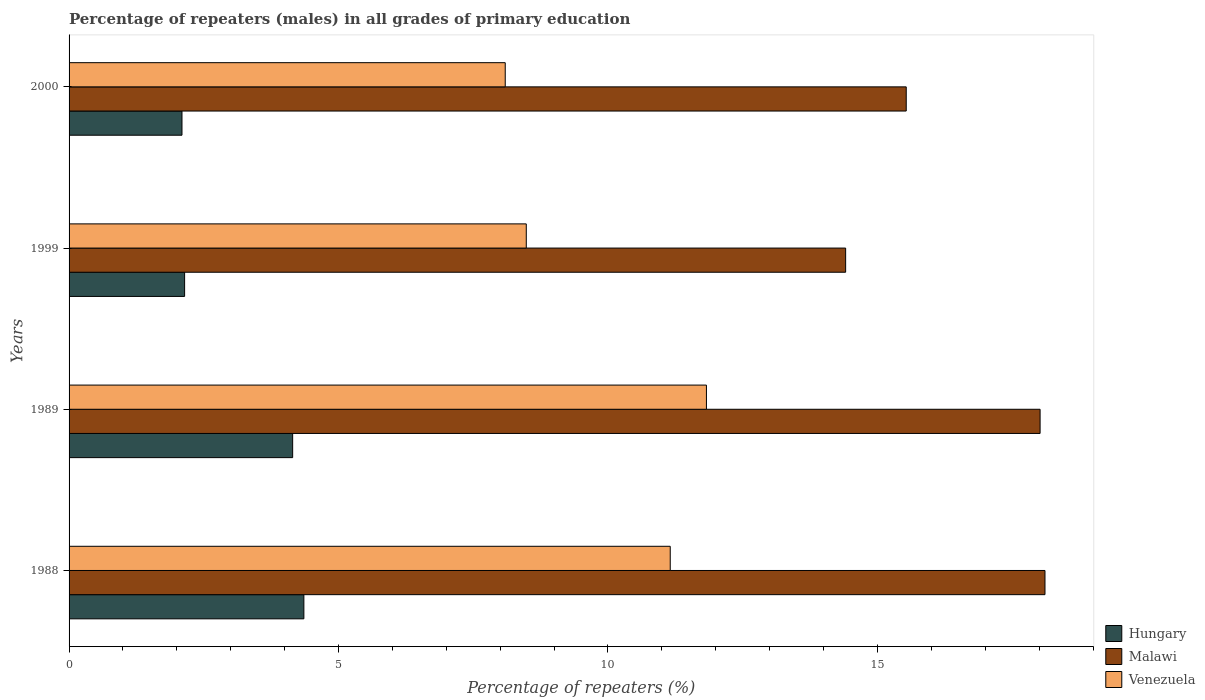How many different coloured bars are there?
Keep it short and to the point. 3. How many groups of bars are there?
Make the answer very short. 4. Are the number of bars per tick equal to the number of legend labels?
Your answer should be very brief. Yes. What is the label of the 4th group of bars from the top?
Keep it short and to the point. 1988. In how many cases, is the number of bars for a given year not equal to the number of legend labels?
Ensure brevity in your answer.  0. What is the percentage of repeaters (males) in Malawi in 1989?
Offer a very short reply. 18.02. Across all years, what is the maximum percentage of repeaters (males) in Malawi?
Provide a short and direct response. 18.11. Across all years, what is the minimum percentage of repeaters (males) in Venezuela?
Your answer should be very brief. 8.09. In which year was the percentage of repeaters (males) in Malawi maximum?
Offer a very short reply. 1988. In which year was the percentage of repeaters (males) in Malawi minimum?
Your answer should be compact. 1999. What is the total percentage of repeaters (males) in Venezuela in the graph?
Give a very brief answer. 39.56. What is the difference between the percentage of repeaters (males) in Hungary in 1988 and that in 1989?
Ensure brevity in your answer.  0.21. What is the difference between the percentage of repeaters (males) in Malawi in 2000 and the percentage of repeaters (males) in Venezuela in 1989?
Make the answer very short. 3.71. What is the average percentage of repeaters (males) in Malawi per year?
Provide a short and direct response. 16.52. In the year 2000, what is the difference between the percentage of repeaters (males) in Malawi and percentage of repeaters (males) in Venezuela?
Ensure brevity in your answer.  7.44. What is the ratio of the percentage of repeaters (males) in Hungary in 1989 to that in 1999?
Ensure brevity in your answer.  1.94. Is the percentage of repeaters (males) in Hungary in 1999 less than that in 2000?
Give a very brief answer. No. What is the difference between the highest and the second highest percentage of repeaters (males) in Malawi?
Your answer should be very brief. 0.09. What is the difference between the highest and the lowest percentage of repeaters (males) in Venezuela?
Make the answer very short. 3.73. In how many years, is the percentage of repeaters (males) in Malawi greater than the average percentage of repeaters (males) in Malawi taken over all years?
Offer a very short reply. 2. Is the sum of the percentage of repeaters (males) in Hungary in 1989 and 1999 greater than the maximum percentage of repeaters (males) in Venezuela across all years?
Give a very brief answer. No. What does the 3rd bar from the top in 1989 represents?
Your answer should be compact. Hungary. What does the 3rd bar from the bottom in 1999 represents?
Provide a succinct answer. Venezuela. Is it the case that in every year, the sum of the percentage of repeaters (males) in Venezuela and percentage of repeaters (males) in Hungary is greater than the percentage of repeaters (males) in Malawi?
Your response must be concise. No. How many bars are there?
Keep it short and to the point. 12. Are the values on the major ticks of X-axis written in scientific E-notation?
Keep it short and to the point. No. Does the graph contain any zero values?
Keep it short and to the point. No. How are the legend labels stacked?
Keep it short and to the point. Vertical. What is the title of the graph?
Give a very brief answer. Percentage of repeaters (males) in all grades of primary education. Does "Gambia, The" appear as one of the legend labels in the graph?
Offer a very short reply. No. What is the label or title of the X-axis?
Your answer should be very brief. Percentage of repeaters (%). What is the Percentage of repeaters (%) of Hungary in 1988?
Your answer should be compact. 4.36. What is the Percentage of repeaters (%) of Malawi in 1988?
Your answer should be very brief. 18.11. What is the Percentage of repeaters (%) in Venezuela in 1988?
Ensure brevity in your answer.  11.16. What is the Percentage of repeaters (%) of Hungary in 1989?
Your answer should be very brief. 4.15. What is the Percentage of repeaters (%) of Malawi in 1989?
Offer a terse response. 18.02. What is the Percentage of repeaters (%) of Venezuela in 1989?
Provide a succinct answer. 11.83. What is the Percentage of repeaters (%) of Hungary in 1999?
Ensure brevity in your answer.  2.14. What is the Percentage of repeaters (%) of Malawi in 1999?
Your answer should be very brief. 14.41. What is the Percentage of repeaters (%) of Venezuela in 1999?
Make the answer very short. 8.48. What is the Percentage of repeaters (%) in Hungary in 2000?
Offer a very short reply. 2.1. What is the Percentage of repeaters (%) of Malawi in 2000?
Give a very brief answer. 15.53. What is the Percentage of repeaters (%) in Venezuela in 2000?
Offer a very short reply. 8.09. Across all years, what is the maximum Percentage of repeaters (%) of Hungary?
Offer a terse response. 4.36. Across all years, what is the maximum Percentage of repeaters (%) in Malawi?
Your answer should be compact. 18.11. Across all years, what is the maximum Percentage of repeaters (%) in Venezuela?
Provide a short and direct response. 11.83. Across all years, what is the minimum Percentage of repeaters (%) of Hungary?
Make the answer very short. 2.1. Across all years, what is the minimum Percentage of repeaters (%) of Malawi?
Provide a short and direct response. 14.41. Across all years, what is the minimum Percentage of repeaters (%) of Venezuela?
Offer a very short reply. 8.09. What is the total Percentage of repeaters (%) of Hungary in the graph?
Offer a terse response. 12.75. What is the total Percentage of repeaters (%) of Malawi in the graph?
Provide a short and direct response. 66.07. What is the total Percentage of repeaters (%) of Venezuela in the graph?
Provide a short and direct response. 39.56. What is the difference between the Percentage of repeaters (%) in Hungary in 1988 and that in 1989?
Your answer should be very brief. 0.21. What is the difference between the Percentage of repeaters (%) of Malawi in 1988 and that in 1989?
Provide a short and direct response. 0.09. What is the difference between the Percentage of repeaters (%) in Venezuela in 1988 and that in 1989?
Make the answer very short. -0.67. What is the difference between the Percentage of repeaters (%) of Hungary in 1988 and that in 1999?
Provide a short and direct response. 2.21. What is the difference between the Percentage of repeaters (%) of Malawi in 1988 and that in 1999?
Provide a short and direct response. 3.7. What is the difference between the Percentage of repeaters (%) in Venezuela in 1988 and that in 1999?
Keep it short and to the point. 2.67. What is the difference between the Percentage of repeaters (%) of Hungary in 1988 and that in 2000?
Ensure brevity in your answer.  2.26. What is the difference between the Percentage of repeaters (%) of Malawi in 1988 and that in 2000?
Provide a short and direct response. 2.57. What is the difference between the Percentage of repeaters (%) in Venezuela in 1988 and that in 2000?
Your answer should be very brief. 3.06. What is the difference between the Percentage of repeaters (%) of Hungary in 1989 and that in 1999?
Make the answer very short. 2. What is the difference between the Percentage of repeaters (%) of Malawi in 1989 and that in 1999?
Give a very brief answer. 3.61. What is the difference between the Percentage of repeaters (%) of Venezuela in 1989 and that in 1999?
Give a very brief answer. 3.34. What is the difference between the Percentage of repeaters (%) of Hungary in 1989 and that in 2000?
Offer a terse response. 2.05. What is the difference between the Percentage of repeaters (%) in Malawi in 1989 and that in 2000?
Ensure brevity in your answer.  2.48. What is the difference between the Percentage of repeaters (%) of Venezuela in 1989 and that in 2000?
Ensure brevity in your answer.  3.73. What is the difference between the Percentage of repeaters (%) of Hungary in 1999 and that in 2000?
Give a very brief answer. 0.05. What is the difference between the Percentage of repeaters (%) in Malawi in 1999 and that in 2000?
Provide a succinct answer. -1.12. What is the difference between the Percentage of repeaters (%) in Venezuela in 1999 and that in 2000?
Offer a terse response. 0.39. What is the difference between the Percentage of repeaters (%) in Hungary in 1988 and the Percentage of repeaters (%) in Malawi in 1989?
Provide a succinct answer. -13.66. What is the difference between the Percentage of repeaters (%) of Hungary in 1988 and the Percentage of repeaters (%) of Venezuela in 1989?
Ensure brevity in your answer.  -7.47. What is the difference between the Percentage of repeaters (%) in Malawi in 1988 and the Percentage of repeaters (%) in Venezuela in 1989?
Offer a terse response. 6.28. What is the difference between the Percentage of repeaters (%) in Hungary in 1988 and the Percentage of repeaters (%) in Malawi in 1999?
Your answer should be very brief. -10.05. What is the difference between the Percentage of repeaters (%) in Hungary in 1988 and the Percentage of repeaters (%) in Venezuela in 1999?
Your answer should be very brief. -4.13. What is the difference between the Percentage of repeaters (%) in Malawi in 1988 and the Percentage of repeaters (%) in Venezuela in 1999?
Make the answer very short. 9.62. What is the difference between the Percentage of repeaters (%) of Hungary in 1988 and the Percentage of repeaters (%) of Malawi in 2000?
Provide a short and direct response. -11.18. What is the difference between the Percentage of repeaters (%) of Hungary in 1988 and the Percentage of repeaters (%) of Venezuela in 2000?
Your answer should be very brief. -3.74. What is the difference between the Percentage of repeaters (%) in Malawi in 1988 and the Percentage of repeaters (%) in Venezuela in 2000?
Give a very brief answer. 10.02. What is the difference between the Percentage of repeaters (%) in Hungary in 1989 and the Percentage of repeaters (%) in Malawi in 1999?
Your answer should be compact. -10.26. What is the difference between the Percentage of repeaters (%) in Hungary in 1989 and the Percentage of repeaters (%) in Venezuela in 1999?
Provide a short and direct response. -4.34. What is the difference between the Percentage of repeaters (%) of Malawi in 1989 and the Percentage of repeaters (%) of Venezuela in 1999?
Offer a very short reply. 9.53. What is the difference between the Percentage of repeaters (%) of Hungary in 1989 and the Percentage of repeaters (%) of Malawi in 2000?
Your answer should be very brief. -11.39. What is the difference between the Percentage of repeaters (%) of Hungary in 1989 and the Percentage of repeaters (%) of Venezuela in 2000?
Your answer should be compact. -3.94. What is the difference between the Percentage of repeaters (%) of Malawi in 1989 and the Percentage of repeaters (%) of Venezuela in 2000?
Provide a succinct answer. 9.93. What is the difference between the Percentage of repeaters (%) in Hungary in 1999 and the Percentage of repeaters (%) in Malawi in 2000?
Offer a very short reply. -13.39. What is the difference between the Percentage of repeaters (%) in Hungary in 1999 and the Percentage of repeaters (%) in Venezuela in 2000?
Ensure brevity in your answer.  -5.95. What is the difference between the Percentage of repeaters (%) of Malawi in 1999 and the Percentage of repeaters (%) of Venezuela in 2000?
Give a very brief answer. 6.32. What is the average Percentage of repeaters (%) in Hungary per year?
Make the answer very short. 3.19. What is the average Percentage of repeaters (%) in Malawi per year?
Offer a very short reply. 16.52. What is the average Percentage of repeaters (%) of Venezuela per year?
Your answer should be very brief. 9.89. In the year 1988, what is the difference between the Percentage of repeaters (%) in Hungary and Percentage of repeaters (%) in Malawi?
Offer a terse response. -13.75. In the year 1988, what is the difference between the Percentage of repeaters (%) of Hungary and Percentage of repeaters (%) of Venezuela?
Provide a short and direct response. -6.8. In the year 1988, what is the difference between the Percentage of repeaters (%) in Malawi and Percentage of repeaters (%) in Venezuela?
Provide a succinct answer. 6.95. In the year 1989, what is the difference between the Percentage of repeaters (%) in Hungary and Percentage of repeaters (%) in Malawi?
Ensure brevity in your answer.  -13.87. In the year 1989, what is the difference between the Percentage of repeaters (%) in Hungary and Percentage of repeaters (%) in Venezuela?
Make the answer very short. -7.68. In the year 1989, what is the difference between the Percentage of repeaters (%) of Malawi and Percentage of repeaters (%) of Venezuela?
Offer a terse response. 6.19. In the year 1999, what is the difference between the Percentage of repeaters (%) of Hungary and Percentage of repeaters (%) of Malawi?
Your response must be concise. -12.27. In the year 1999, what is the difference between the Percentage of repeaters (%) in Hungary and Percentage of repeaters (%) in Venezuela?
Offer a terse response. -6.34. In the year 1999, what is the difference between the Percentage of repeaters (%) in Malawi and Percentage of repeaters (%) in Venezuela?
Give a very brief answer. 5.93. In the year 2000, what is the difference between the Percentage of repeaters (%) of Hungary and Percentage of repeaters (%) of Malawi?
Make the answer very short. -13.44. In the year 2000, what is the difference between the Percentage of repeaters (%) of Hungary and Percentage of repeaters (%) of Venezuela?
Provide a short and direct response. -6. In the year 2000, what is the difference between the Percentage of repeaters (%) of Malawi and Percentage of repeaters (%) of Venezuela?
Offer a very short reply. 7.44. What is the ratio of the Percentage of repeaters (%) in Hungary in 1988 to that in 1989?
Your answer should be compact. 1.05. What is the ratio of the Percentage of repeaters (%) of Venezuela in 1988 to that in 1989?
Give a very brief answer. 0.94. What is the ratio of the Percentage of repeaters (%) of Hungary in 1988 to that in 1999?
Your response must be concise. 2.03. What is the ratio of the Percentage of repeaters (%) in Malawi in 1988 to that in 1999?
Provide a succinct answer. 1.26. What is the ratio of the Percentage of repeaters (%) of Venezuela in 1988 to that in 1999?
Give a very brief answer. 1.31. What is the ratio of the Percentage of repeaters (%) of Hungary in 1988 to that in 2000?
Give a very brief answer. 2.08. What is the ratio of the Percentage of repeaters (%) in Malawi in 1988 to that in 2000?
Your response must be concise. 1.17. What is the ratio of the Percentage of repeaters (%) in Venezuela in 1988 to that in 2000?
Provide a short and direct response. 1.38. What is the ratio of the Percentage of repeaters (%) of Hungary in 1989 to that in 1999?
Your answer should be very brief. 1.94. What is the ratio of the Percentage of repeaters (%) of Malawi in 1989 to that in 1999?
Offer a very short reply. 1.25. What is the ratio of the Percentage of repeaters (%) of Venezuela in 1989 to that in 1999?
Make the answer very short. 1.39. What is the ratio of the Percentage of repeaters (%) in Hungary in 1989 to that in 2000?
Your answer should be compact. 1.98. What is the ratio of the Percentage of repeaters (%) of Malawi in 1989 to that in 2000?
Your answer should be compact. 1.16. What is the ratio of the Percentage of repeaters (%) of Venezuela in 1989 to that in 2000?
Offer a terse response. 1.46. What is the ratio of the Percentage of repeaters (%) of Hungary in 1999 to that in 2000?
Ensure brevity in your answer.  1.02. What is the ratio of the Percentage of repeaters (%) in Malawi in 1999 to that in 2000?
Provide a succinct answer. 0.93. What is the ratio of the Percentage of repeaters (%) in Venezuela in 1999 to that in 2000?
Make the answer very short. 1.05. What is the difference between the highest and the second highest Percentage of repeaters (%) of Hungary?
Offer a very short reply. 0.21. What is the difference between the highest and the second highest Percentage of repeaters (%) of Malawi?
Your answer should be very brief. 0.09. What is the difference between the highest and the second highest Percentage of repeaters (%) in Venezuela?
Offer a terse response. 0.67. What is the difference between the highest and the lowest Percentage of repeaters (%) of Hungary?
Your answer should be compact. 2.26. What is the difference between the highest and the lowest Percentage of repeaters (%) in Malawi?
Make the answer very short. 3.7. What is the difference between the highest and the lowest Percentage of repeaters (%) in Venezuela?
Provide a short and direct response. 3.73. 